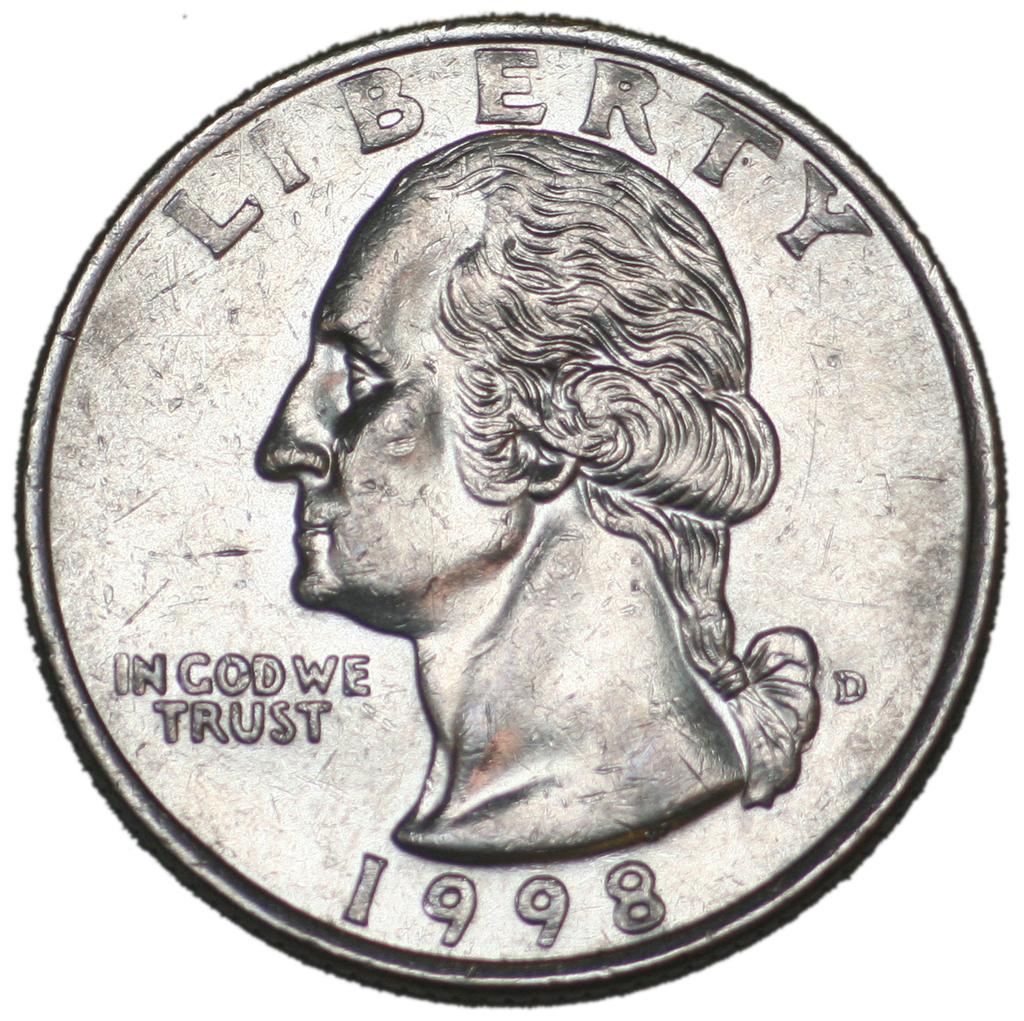<image>
Present a compact description of the photo's key features. A silver Liberty quarter was minted in 1998. 